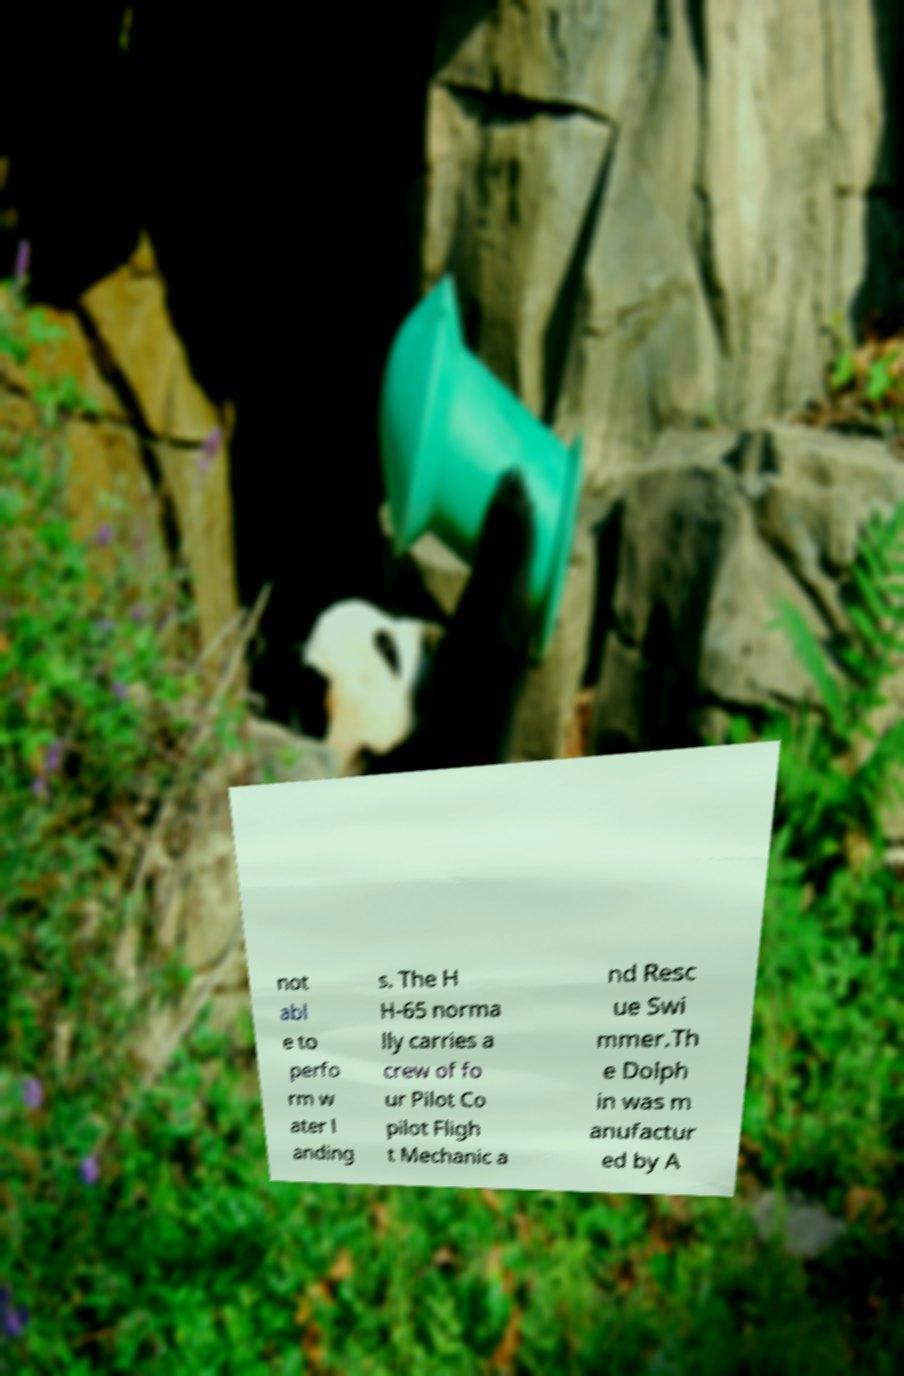I need the written content from this picture converted into text. Can you do that? not abl e to perfo rm w ater l anding s. The H H-65 norma lly carries a crew of fo ur Pilot Co pilot Fligh t Mechanic a nd Resc ue Swi mmer.Th e Dolph in was m anufactur ed by A 